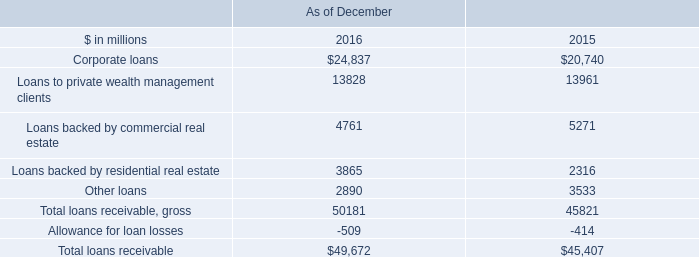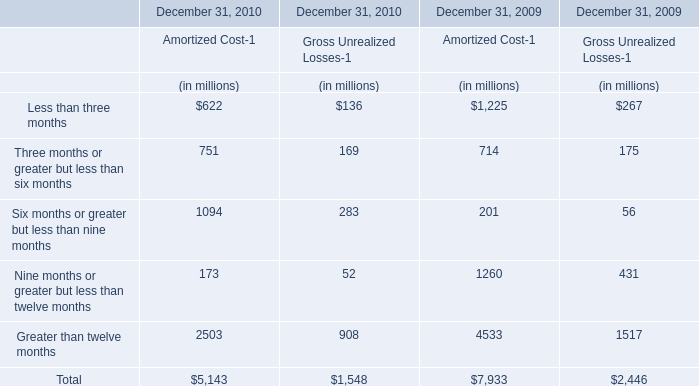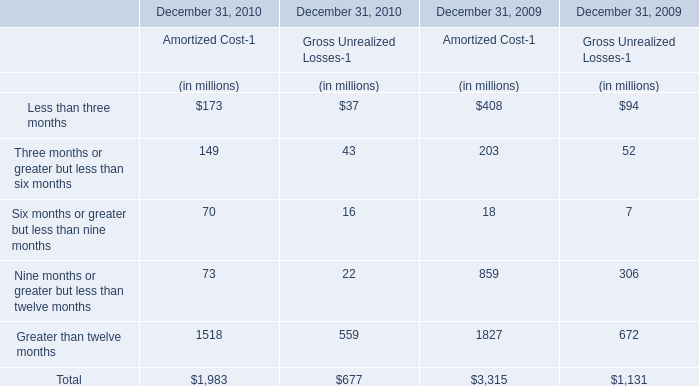What is the sum of elements for Amortized Cost-1 in 2010? (in million) 
Computations: ((((173 + 149) + 70) + 73) + 1518)
Answer: 1983.0. 